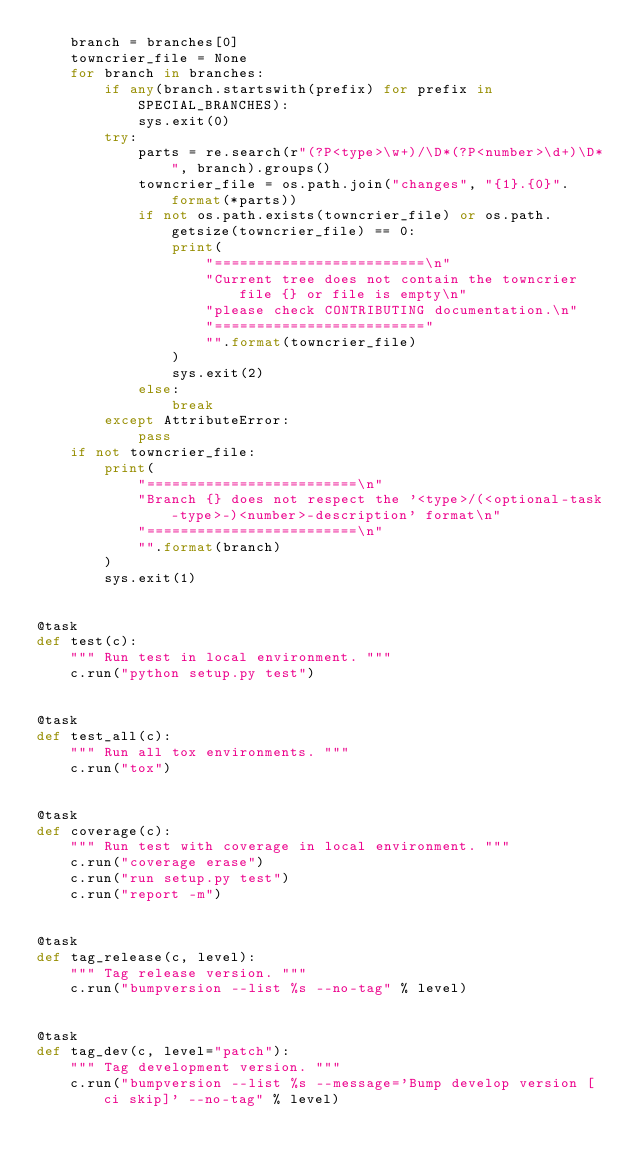<code> <loc_0><loc_0><loc_500><loc_500><_Python_>    branch = branches[0]
    towncrier_file = None
    for branch in branches:
        if any(branch.startswith(prefix) for prefix in SPECIAL_BRANCHES):
            sys.exit(0)
        try:
            parts = re.search(r"(?P<type>\w+)/\D*(?P<number>\d+)\D*", branch).groups()
            towncrier_file = os.path.join("changes", "{1}.{0}".format(*parts))
            if not os.path.exists(towncrier_file) or os.path.getsize(towncrier_file) == 0:
                print(
                    "=========================\n"
                    "Current tree does not contain the towncrier file {} or file is empty\n"
                    "please check CONTRIBUTING documentation.\n"
                    "========================="
                    "".format(towncrier_file)
                )
                sys.exit(2)
            else:
                break
        except AttributeError:
            pass
    if not towncrier_file:
        print(
            "=========================\n"
            "Branch {} does not respect the '<type>/(<optional-task-type>-)<number>-description' format\n"
            "=========================\n"
            "".format(branch)
        )
        sys.exit(1)


@task
def test(c):
    """ Run test in local environment. """
    c.run("python setup.py test")


@task
def test_all(c):
    """ Run all tox environments. """
    c.run("tox")


@task
def coverage(c):
    """ Run test with coverage in local environment. """
    c.run("coverage erase")
    c.run("run setup.py test")
    c.run("report -m")


@task
def tag_release(c, level):
    """ Tag release version. """
    c.run("bumpversion --list %s --no-tag" % level)


@task
def tag_dev(c, level="patch"):
    """ Tag development version. """
    c.run("bumpversion --list %s --message='Bump develop version [ci skip]' --no-tag" % level)
</code> 